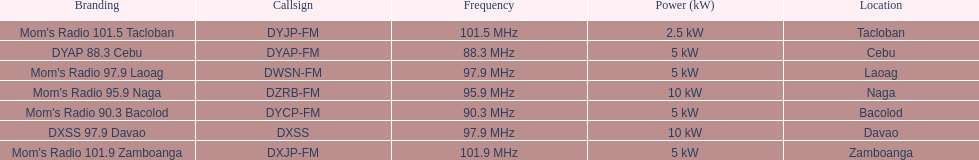Give me the full table as a dictionary. {'header': ['Branding', 'Callsign', 'Frequency', 'Power (kW)', 'Location'], 'rows': [["Mom's Radio 101.5 Tacloban", 'DYJP-FM', '101.5\xa0MHz', '2.5\xa0kW', 'Tacloban'], ['DYAP 88.3 Cebu', 'DYAP-FM', '88.3\xa0MHz', '5\xa0kW', 'Cebu'], ["Mom's Radio 97.9 Laoag", 'DWSN-FM', '97.9\xa0MHz', '5\xa0kW', 'Laoag'], ["Mom's Radio 95.9 Naga", 'DZRB-FM', '95.9\xa0MHz', '10\xa0kW', 'Naga'], ["Mom's Radio 90.3 Bacolod", 'DYCP-FM', '90.3\xa0MHz', '5\xa0kW', 'Bacolod'], ['DXSS 97.9 Davao', 'DXSS', '97.9\xa0MHz', '10\xa0kW', 'Davao'], ["Mom's Radio 101.9 Zamboanga", 'DXJP-FM', '101.9\xa0MHz', '5\xa0kW', 'Zamboanga']]} How many times is the frequency greater than 95? 5. 